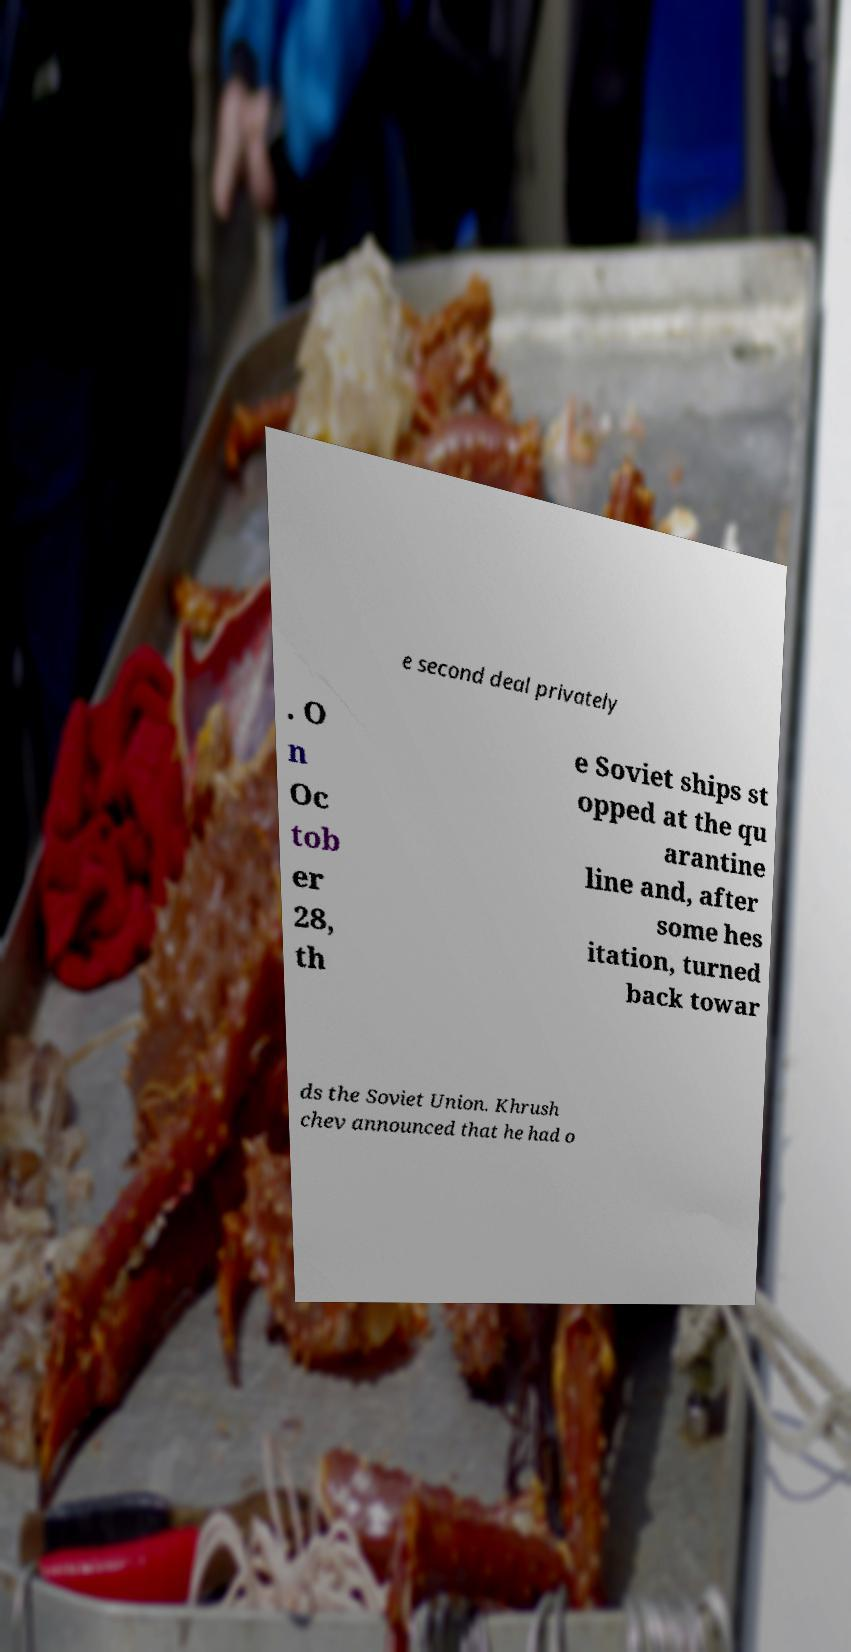What messages or text are displayed in this image? I need them in a readable, typed format. e second deal privately . O n Oc tob er 28, th e Soviet ships st opped at the qu arantine line and, after some hes itation, turned back towar ds the Soviet Union. Khrush chev announced that he had o 